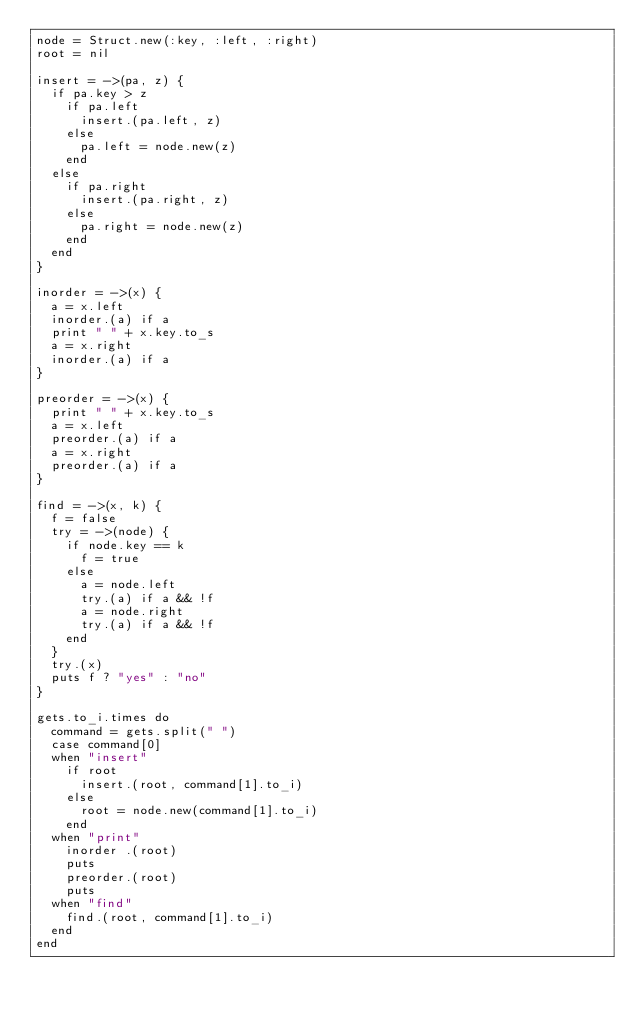Convert code to text. <code><loc_0><loc_0><loc_500><loc_500><_Ruby_>node = Struct.new(:key, :left, :right)
root = nil

insert = ->(pa, z) {
  if pa.key > z
    if pa.left
      insert.(pa.left, z)
    else
      pa.left = node.new(z)
    end
  else
    if pa.right
      insert.(pa.right, z)
    else
      pa.right = node.new(z)
    end
  end
}

inorder = ->(x) {
  a = x.left
  inorder.(a) if a
  print " " + x.key.to_s
  a = x.right
  inorder.(a) if a
}

preorder = ->(x) {
  print " " + x.key.to_s
  a = x.left
  preorder.(a) if a
  a = x.right
  preorder.(a) if a
}

find = ->(x, k) {
  f = false
  try = ->(node) {
    if node.key == k
      f = true
    else
      a = node.left
      try.(a) if a && !f
      a = node.right
      try.(a) if a && !f
    end
  }
  try.(x) 
  puts f ? "yes" : "no" 
}

gets.to_i.times do
  command = gets.split(" ")
  case command[0]
  when "insert"
    if root
      insert.(root, command[1].to_i)
    else
      root = node.new(command[1].to_i)
    end
  when "print"
    inorder .(root)
    puts
    preorder.(root)
    puts
  when "find"
    find.(root, command[1].to_i)
  end
end
</code> 